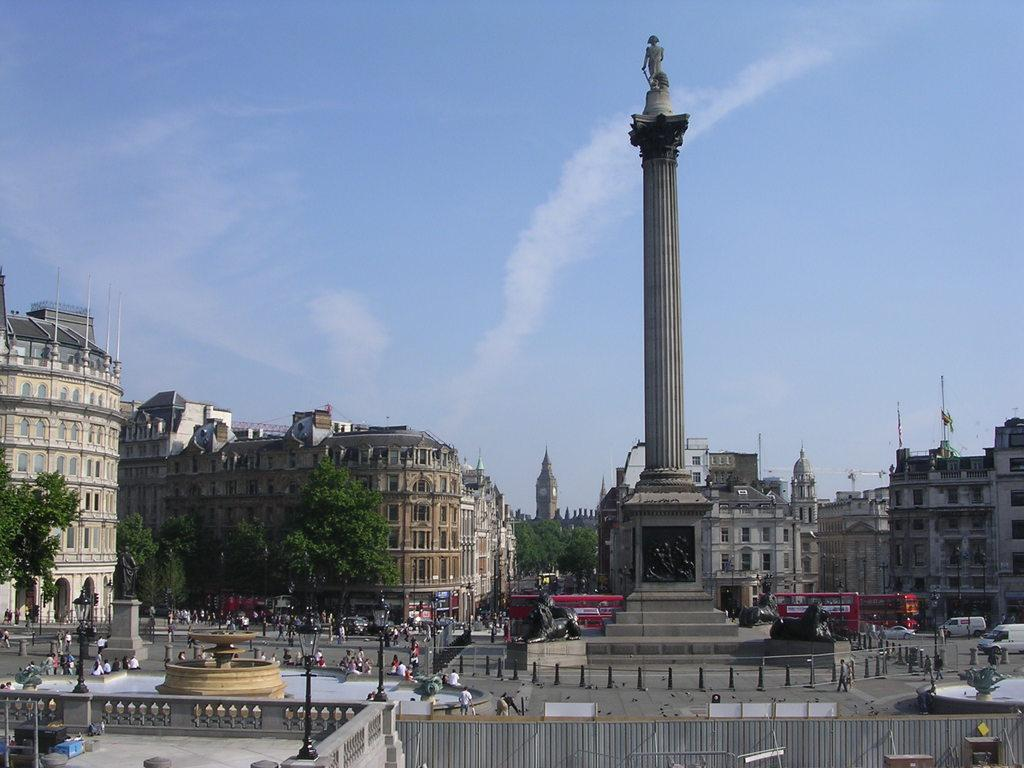What can be seen in the background of the image? In the background of the image, there are buildings, trees, and a sky visible. What is present on the road in the image? There are vehicles on the road in the image. Are there any living beings in the image? Yes, there are people in the image. What type of structures can be seen in the image? There are poles and statues in the image. What additional features are present in the image? There are lights, a water fountain, and other objects in the image. What type of cakes are being served on the tongue of the statue in the image? There is no tongue or cakes present in the image. What type of paper is being used to wrap the statues in the image? There is no paper or wrapping of statues present in the image. 